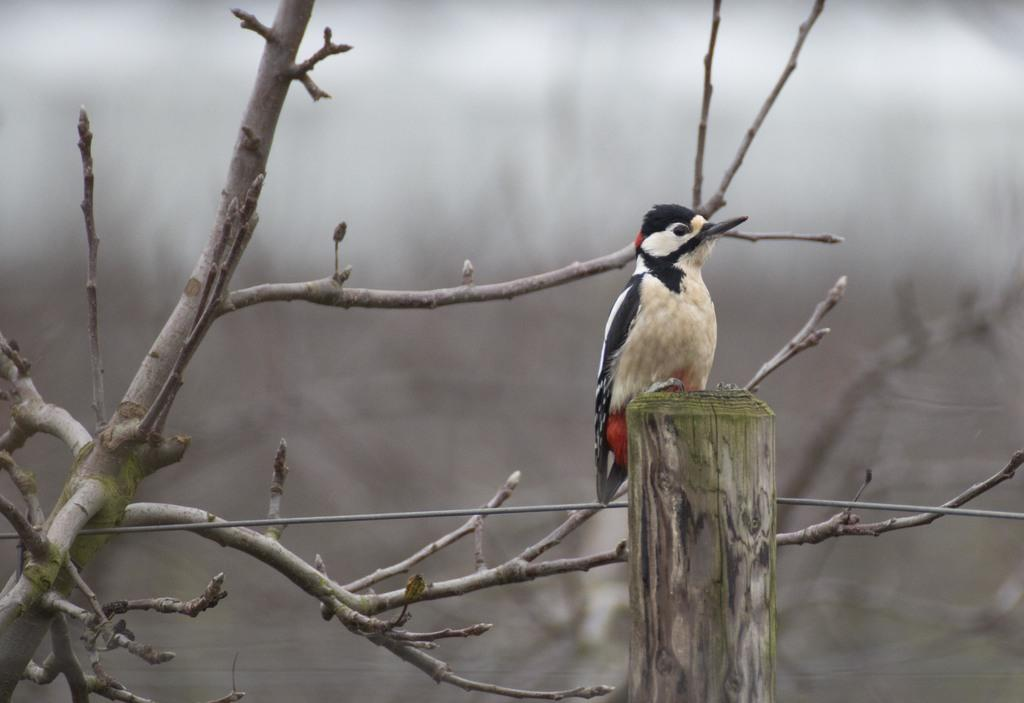What type of animal is in the picture? There is a bird in the picture. How is the bird positioned in the image? The bird is on a wooden stick. What other natural element is present in the picture? There is a tree stem in the picture. What type of surprise can be seen in the picture? There is no surprise present in the image; it features a bird on a wooden stick and a tree stem. Can you tell me how many coaches are visible in the picture? There are no coaches present in the image. 